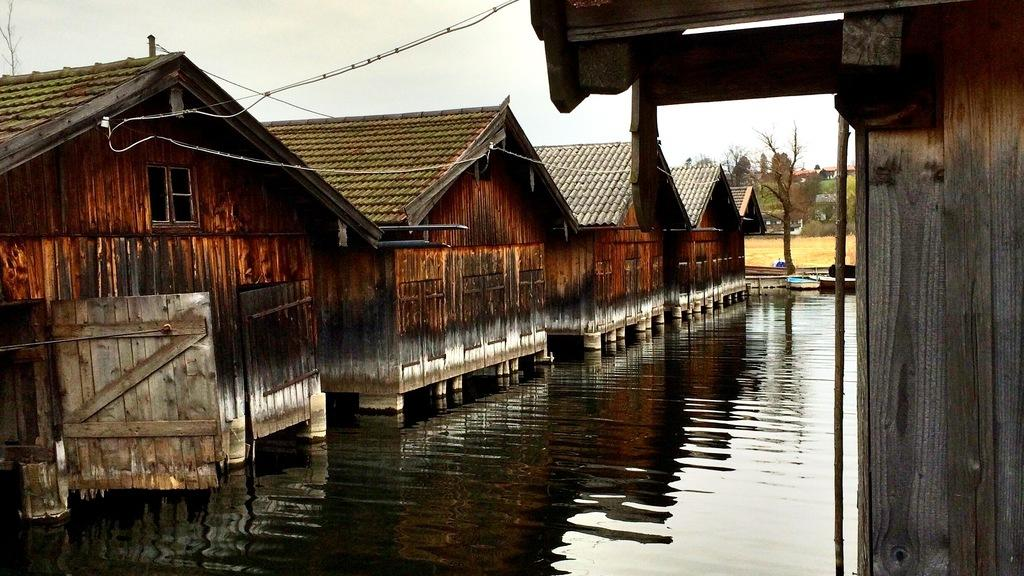What type of structures can be seen in the image? There are sheds in the image. What else can be seen in the image besides the sheds? There are wires, trees, poles, water, ground, and sky visible in the image. Can you describe the natural elements in the image? There are trees and water visible in the image. What is visible at the top of the image? The sky is visible at the top of the image. How much tax is being paid on the cars in the image? There are no cars present in the image, so it is not possible to determine the tax being paid on them. 